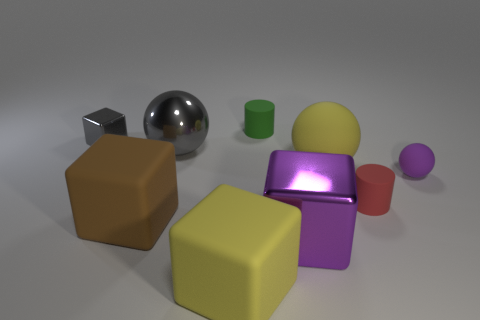Subtract all cylinders. How many objects are left? 7 Subtract 0 purple cylinders. How many objects are left? 9 Subtract all cyan balls. Subtract all big shiny things. How many objects are left? 7 Add 6 green cylinders. How many green cylinders are left? 7 Add 2 big gray cylinders. How many big gray cylinders exist? 2 